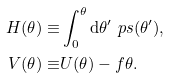<formula> <loc_0><loc_0><loc_500><loc_500>H ( \theta ) \equiv & \int _ { 0 } ^ { \theta } { \mathrm d } \theta ^ { \prime } \ p s ( \theta ^ { \prime } ) , \\ V ( \theta ) \equiv & U ( \theta ) - f \theta .</formula> 